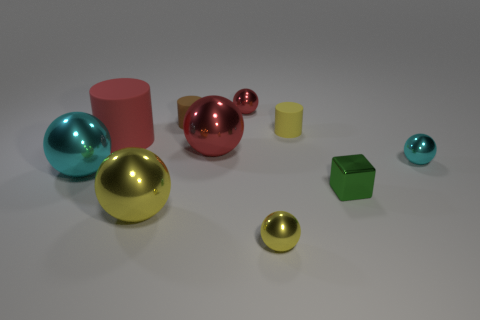Subtract all big cyan metallic balls. How many balls are left? 5 Subtract all brown spheres. Subtract all brown cylinders. How many spheres are left? 6 Subtract all cylinders. How many objects are left? 7 Subtract all large red metallic balls. Subtract all cyan spheres. How many objects are left? 7 Add 8 large rubber things. How many large rubber things are left? 9 Add 3 red rubber objects. How many red rubber objects exist? 4 Subtract 1 yellow cylinders. How many objects are left? 9 